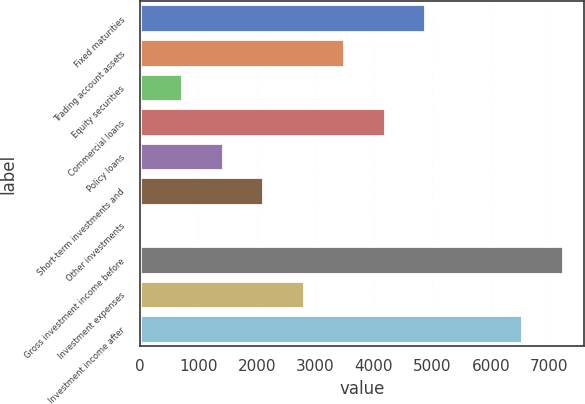<chart> <loc_0><loc_0><loc_500><loc_500><bar_chart><fcel>Fixed maturities<fcel>Trading account assets<fcel>Equity securities<fcel>Commercial loans<fcel>Policy loans<fcel>Short-term investments and<fcel>Other investments<fcel>Gross investment income before<fcel>Investment expenses<fcel>Investment income after<nl><fcel>4882.7<fcel>3496.5<fcel>724.1<fcel>4189.6<fcel>1417.2<fcel>2110.3<fcel>31<fcel>7230.1<fcel>2803.4<fcel>6537<nl></chart> 